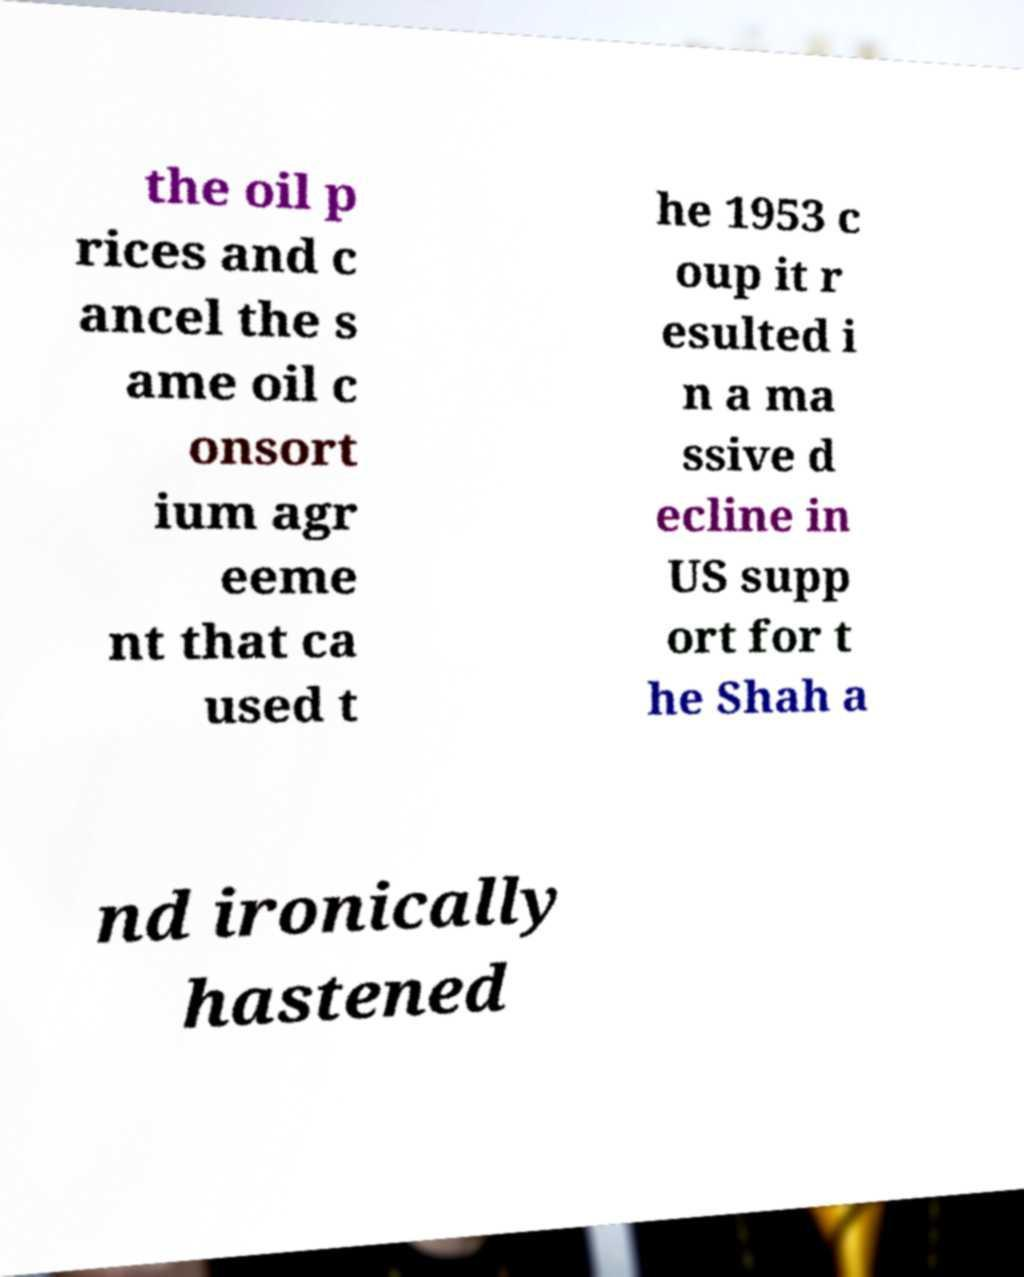Could you extract and type out the text from this image? the oil p rices and c ancel the s ame oil c onsort ium agr eeme nt that ca used t he 1953 c oup it r esulted i n a ma ssive d ecline in US supp ort for t he Shah a nd ironically hastened 